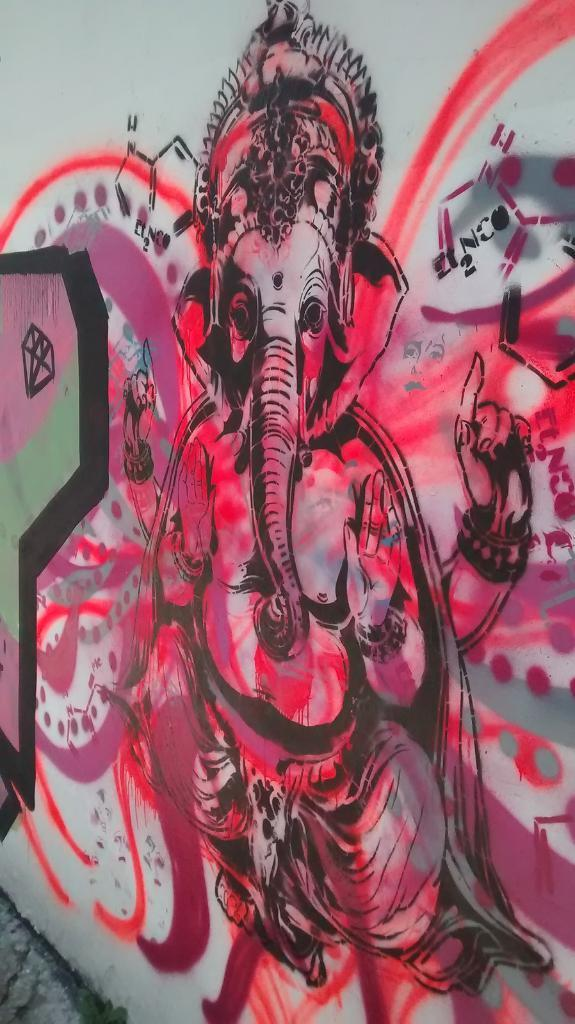What is present on the wall in the image? There is a painting on the wall. Can you describe the painting on the wall? Unfortunately, the facts provided do not give any details about the painting. What historical event is depicted in the painting on the wall? There is no information provided about the content of the painting, so it cannot be determined if it depicts any historical event. 